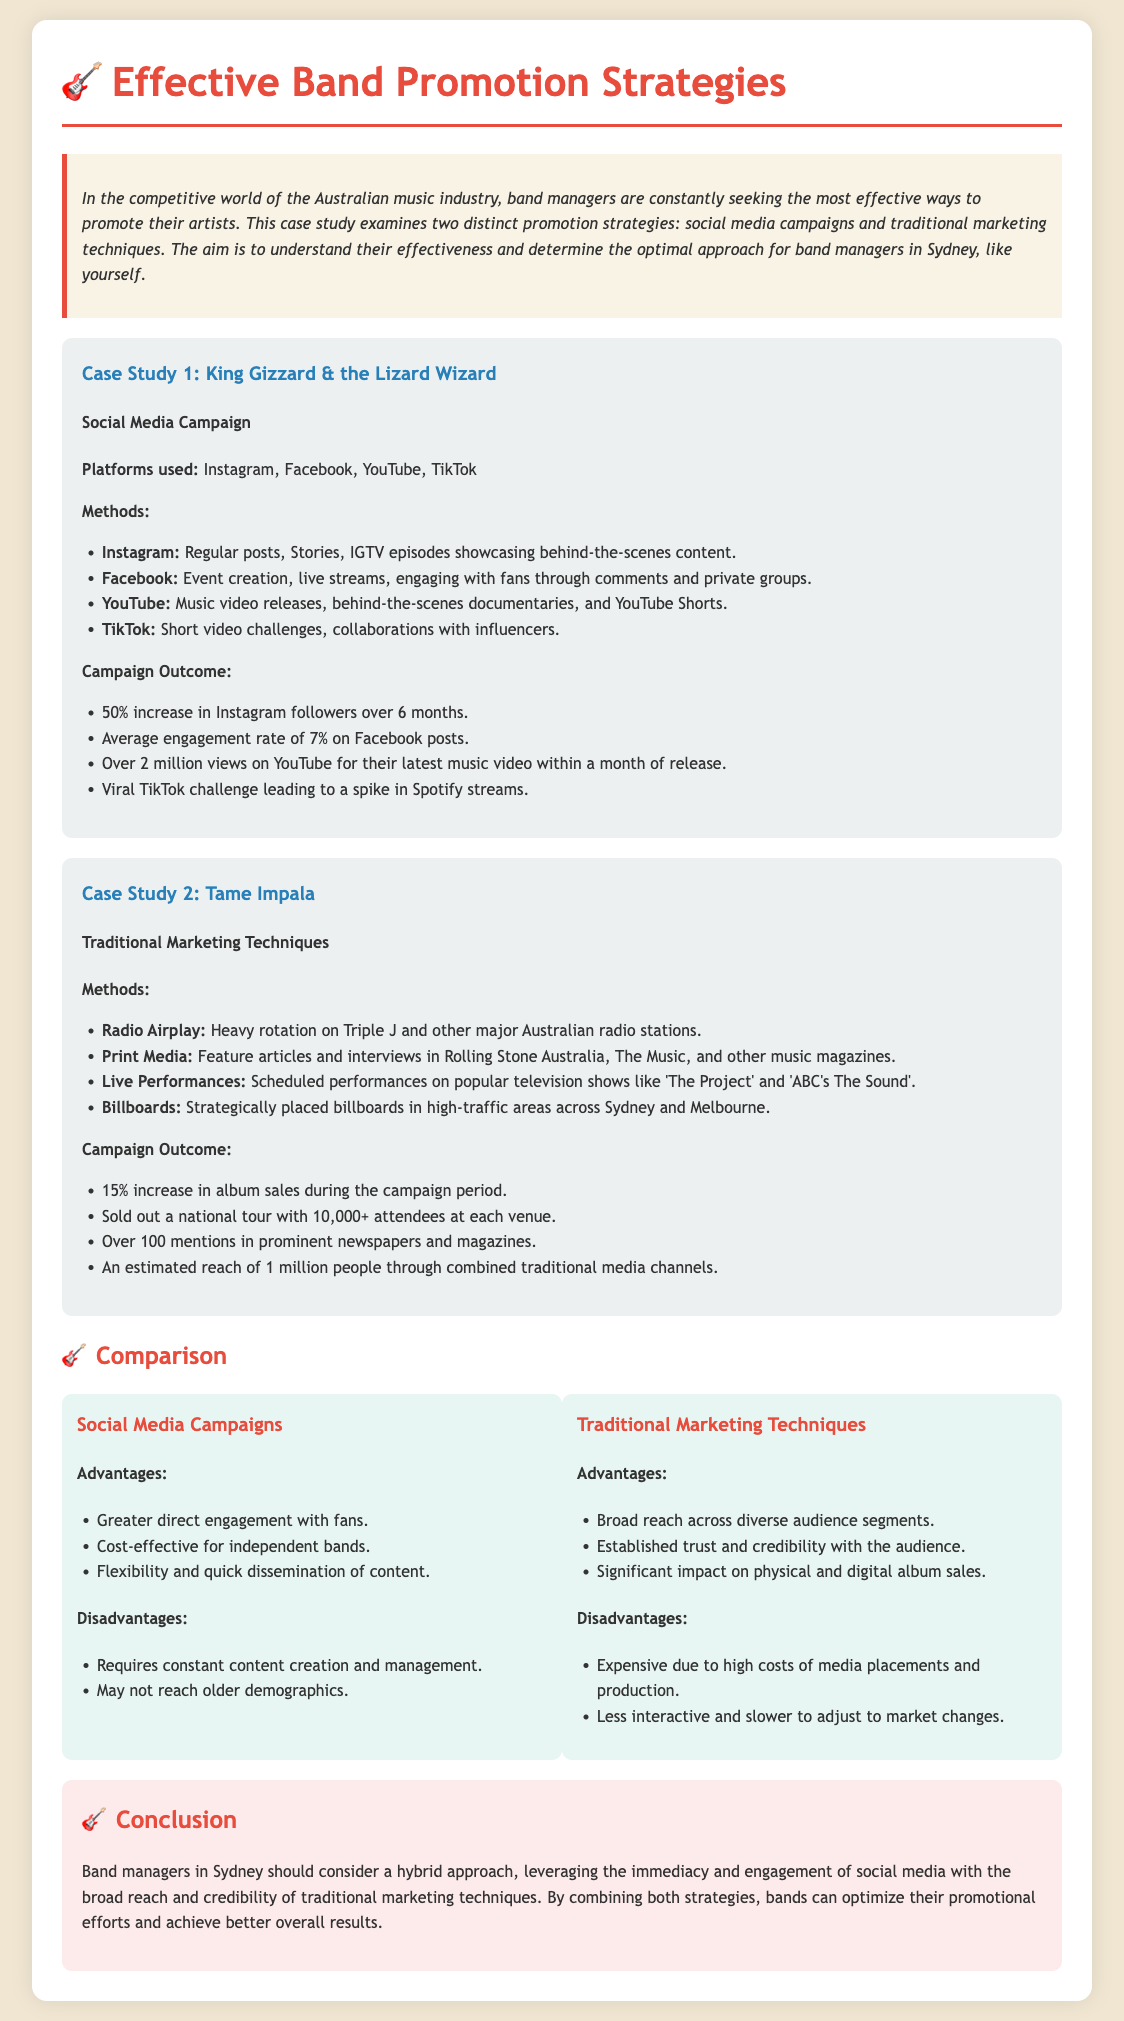what is the name of the first band studied? The first band studied in the case is King Gizzard & the Lizard Wizard.
Answer: King Gizzard & the Lizard Wizard which platform was NOT used in King Gizzard's campaign? The platform not used in King Gizzard's campaign is Twitter.
Answer: Twitter what was the percentage increase in Instagram followers for King Gizzard? The increase in Instagram followers for King Gizzard was 50%.
Answer: 50% how many attendees were at each venue for Tame Impala's national tour? Each venue for Tame Impala's national tour had over 10,000 attendees.
Answer: 10,000+ what is one disadvantage of social media campaigns? One disadvantage of social media campaigns is that they require constant content creation and management.
Answer: Constant content creation what is a traditional marketing technique used by Tame Impala? A traditional marketing technique used by Tame Impala is radio airplay.
Answer: Radio Airplay what is the estimated reach of Tame Impala's traditional media efforts? The estimated reach is 1 million people through combined traditional media channels.
Answer: 1 million what combination of strategies is recommended for band managers? The recommended combination of strategies for band managers is a hybrid approach.
Answer: Hybrid approach 